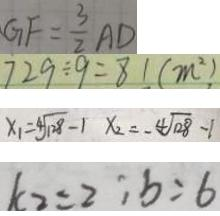<formula> <loc_0><loc_0><loc_500><loc_500>G F = \frac { 3 } { 2 } A D 
 7 2 9 \div 9 = 8 1 ( m ^ { 2 } ) 
 x _ { 1 } = 4 \sqrt { 1 2 8 } - 1 x _ { 2 } = - 4 \sqrt { 1 2 8 } - 1 
 k _ { 2 } = 2 ; b = 6</formula> 